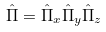Convert formula to latex. <formula><loc_0><loc_0><loc_500><loc_500>\hat { \Pi } = \hat { \Pi } _ { x } \hat { \Pi } _ { y } \hat { \Pi } _ { z }</formula> 